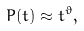Convert formula to latex. <formula><loc_0><loc_0><loc_500><loc_500>P ( t ) \approx t ^ { \vartheta } ,</formula> 